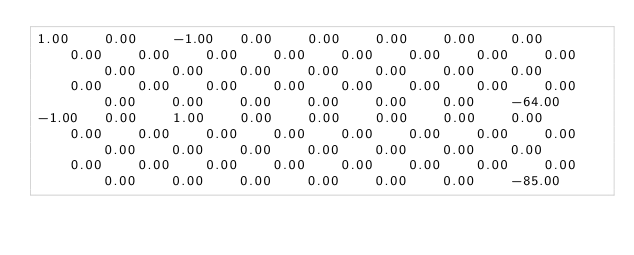Convert code to text. <code><loc_0><loc_0><loc_500><loc_500><_Matlab_>1.00	0.00	-1.00	0.00	0.00	0.00	0.00	0.00	0.00	0.00	0.00	0.00	0.00	0.00	0.00	0.00	0.00	0.00	0.00	0.00	0.00	0.00	0.00	0.00	0.00	0.00	0.00	0.00	0.00	0.00	0.00	0.00	0.00	0.00	0.00	0.00	0.00	-64.00
-1.00	0.00	1.00	0.00	0.00	0.00	0.00	0.00	0.00	0.00	0.00	0.00	0.00	0.00	0.00	0.00	0.00	0.00	0.00	0.00	0.00	0.00	0.00	0.00	0.00	0.00	0.00	0.00	0.00	0.00	0.00	0.00	0.00	0.00	0.00	0.00	0.00	-85.00</code> 